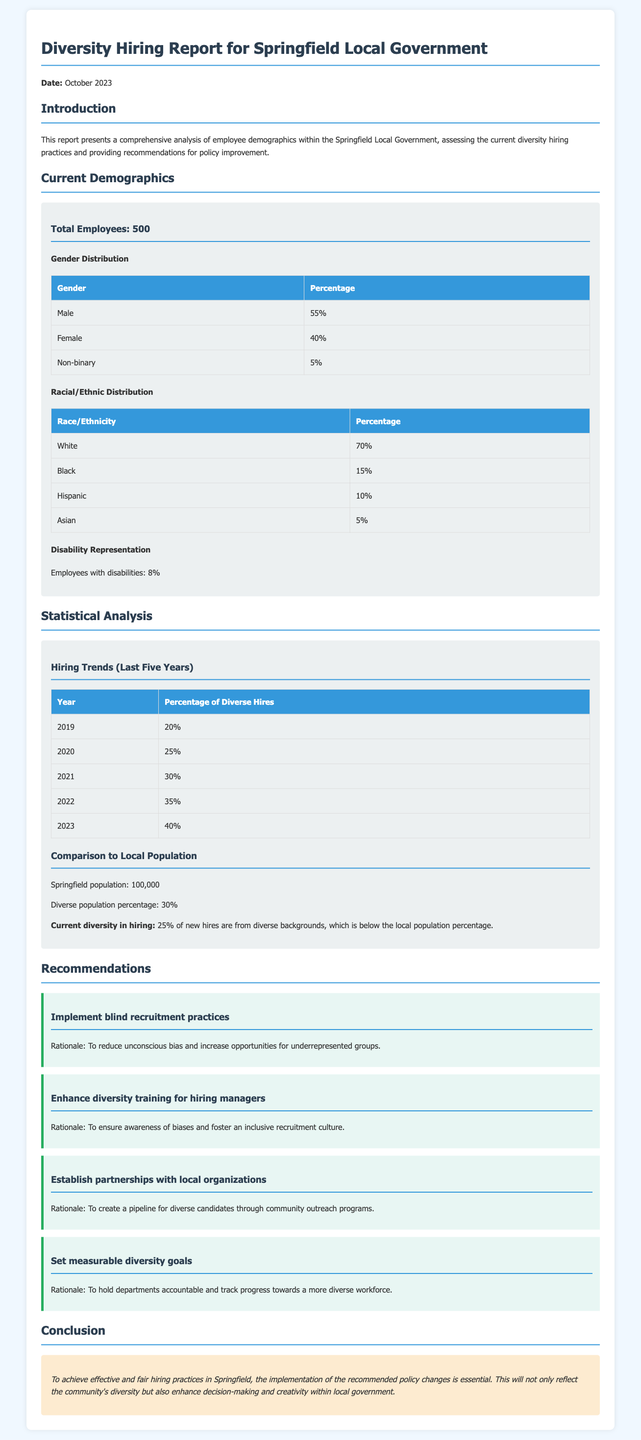What is the total number of employees? The total number of employees is stated in the document as 500.
Answer: 500 What percentage of employees are female? The document lists the percentage of female employees as 40%.
Answer: 40% What is the percentage of diverse hires in 2023? The table for hiring trends indicates the percentage of diverse hires in 2023 is 40%.
Answer: 40% What is the racial/ethnic percentage of Black employees? The document specifies that the percentage of Black employees is 15%.
Answer: 15% What is one recommendation for improving diversity hiring practices? The report provides several recommendations, one being to implement blind recruitment practices.
Answer: Implement blind recruitment practices What is the comparison of current diversity in hiring to the local population percentage? The document states that current diversity in hiring (25%) is below the local population percentage (30%).
Answer: Below How many years of hiring trends are analyzed in this report? The report analyzes hiring trends over the last five years.
Answer: Five years What percentage of employees represent disabilities? The document mentions that 8% of employees have disabilities.
Answer: 8% 